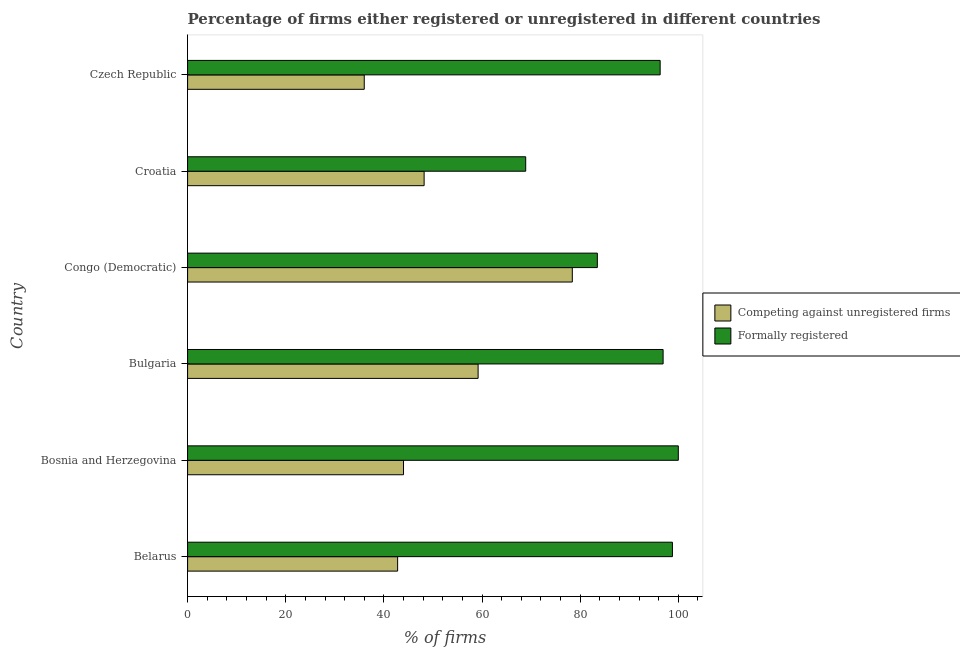What is the label of the 1st group of bars from the top?
Your answer should be compact. Czech Republic. In how many cases, is the number of bars for a given country not equal to the number of legend labels?
Your response must be concise. 0. What is the percentage of registered firms in Bosnia and Herzegovina?
Keep it short and to the point. 44. Across all countries, what is the maximum percentage of formally registered firms?
Give a very brief answer. 100. Across all countries, what is the minimum percentage of formally registered firms?
Your answer should be compact. 68.9. In which country was the percentage of registered firms maximum?
Offer a very short reply. Congo (Democratic). In which country was the percentage of formally registered firms minimum?
Give a very brief answer. Croatia. What is the total percentage of formally registered firms in the graph?
Ensure brevity in your answer.  544.4. What is the difference between the percentage of formally registered firms in Bosnia and Herzegovina and that in Czech Republic?
Your answer should be very brief. 3.7. What is the difference between the percentage of registered firms in Croatia and the percentage of formally registered firms in Congo (Democratic)?
Give a very brief answer. -35.3. What is the average percentage of formally registered firms per country?
Your answer should be very brief. 90.73. What is the difference between the percentage of formally registered firms and percentage of registered firms in Bulgaria?
Give a very brief answer. 37.7. What is the ratio of the percentage of formally registered firms in Bulgaria to that in Congo (Democratic)?
Provide a short and direct response. 1.16. What is the difference between the highest and the second highest percentage of registered firms?
Offer a very short reply. 19.2. What is the difference between the highest and the lowest percentage of formally registered firms?
Your response must be concise. 31.1. Is the sum of the percentage of formally registered firms in Belarus and Bosnia and Herzegovina greater than the maximum percentage of registered firms across all countries?
Your response must be concise. Yes. What does the 2nd bar from the top in Congo (Democratic) represents?
Provide a succinct answer. Competing against unregistered firms. What does the 1st bar from the bottom in Bosnia and Herzegovina represents?
Your answer should be very brief. Competing against unregistered firms. How many bars are there?
Provide a short and direct response. 12. Are the values on the major ticks of X-axis written in scientific E-notation?
Provide a succinct answer. No. Does the graph contain any zero values?
Provide a succinct answer. No. Does the graph contain grids?
Make the answer very short. No. Where does the legend appear in the graph?
Provide a succinct answer. Center right. How are the legend labels stacked?
Your answer should be compact. Vertical. What is the title of the graph?
Provide a short and direct response. Percentage of firms either registered or unregistered in different countries. Does "Domestic Liabilities" appear as one of the legend labels in the graph?
Offer a very short reply. No. What is the label or title of the X-axis?
Your answer should be compact. % of firms. What is the % of firms of Competing against unregistered firms in Belarus?
Give a very brief answer. 42.8. What is the % of firms in Formally registered in Belarus?
Your answer should be very brief. 98.8. What is the % of firms in Competing against unregistered firms in Bulgaria?
Your response must be concise. 59.2. What is the % of firms of Formally registered in Bulgaria?
Give a very brief answer. 96.9. What is the % of firms of Competing against unregistered firms in Congo (Democratic)?
Give a very brief answer. 78.4. What is the % of firms of Formally registered in Congo (Democratic)?
Ensure brevity in your answer.  83.5. What is the % of firms of Competing against unregistered firms in Croatia?
Keep it short and to the point. 48.2. What is the % of firms of Formally registered in Croatia?
Provide a short and direct response. 68.9. What is the % of firms of Competing against unregistered firms in Czech Republic?
Your answer should be compact. 36. What is the % of firms of Formally registered in Czech Republic?
Your response must be concise. 96.3. Across all countries, what is the maximum % of firms in Competing against unregistered firms?
Offer a terse response. 78.4. Across all countries, what is the maximum % of firms of Formally registered?
Provide a short and direct response. 100. Across all countries, what is the minimum % of firms in Formally registered?
Offer a terse response. 68.9. What is the total % of firms of Competing against unregistered firms in the graph?
Make the answer very short. 308.6. What is the total % of firms in Formally registered in the graph?
Offer a terse response. 544.4. What is the difference between the % of firms in Competing against unregistered firms in Belarus and that in Bulgaria?
Keep it short and to the point. -16.4. What is the difference between the % of firms in Competing against unregistered firms in Belarus and that in Congo (Democratic)?
Your answer should be compact. -35.6. What is the difference between the % of firms in Formally registered in Belarus and that in Croatia?
Provide a succinct answer. 29.9. What is the difference between the % of firms in Formally registered in Belarus and that in Czech Republic?
Make the answer very short. 2.5. What is the difference between the % of firms in Competing against unregistered firms in Bosnia and Herzegovina and that in Bulgaria?
Give a very brief answer. -15.2. What is the difference between the % of firms in Competing against unregistered firms in Bosnia and Herzegovina and that in Congo (Democratic)?
Your answer should be very brief. -34.4. What is the difference between the % of firms of Formally registered in Bosnia and Herzegovina and that in Croatia?
Your answer should be very brief. 31.1. What is the difference between the % of firms of Competing against unregistered firms in Bosnia and Herzegovina and that in Czech Republic?
Keep it short and to the point. 8. What is the difference between the % of firms of Formally registered in Bosnia and Herzegovina and that in Czech Republic?
Provide a short and direct response. 3.7. What is the difference between the % of firms of Competing against unregistered firms in Bulgaria and that in Congo (Democratic)?
Give a very brief answer. -19.2. What is the difference between the % of firms of Competing against unregistered firms in Bulgaria and that in Croatia?
Make the answer very short. 11. What is the difference between the % of firms in Formally registered in Bulgaria and that in Croatia?
Provide a succinct answer. 28. What is the difference between the % of firms in Competing against unregistered firms in Bulgaria and that in Czech Republic?
Offer a terse response. 23.2. What is the difference between the % of firms in Competing against unregistered firms in Congo (Democratic) and that in Croatia?
Your answer should be very brief. 30.2. What is the difference between the % of firms of Competing against unregistered firms in Congo (Democratic) and that in Czech Republic?
Your answer should be compact. 42.4. What is the difference between the % of firms of Formally registered in Croatia and that in Czech Republic?
Ensure brevity in your answer.  -27.4. What is the difference between the % of firms in Competing against unregistered firms in Belarus and the % of firms in Formally registered in Bosnia and Herzegovina?
Offer a terse response. -57.2. What is the difference between the % of firms in Competing against unregistered firms in Belarus and the % of firms in Formally registered in Bulgaria?
Give a very brief answer. -54.1. What is the difference between the % of firms in Competing against unregistered firms in Belarus and the % of firms in Formally registered in Congo (Democratic)?
Offer a terse response. -40.7. What is the difference between the % of firms in Competing against unregistered firms in Belarus and the % of firms in Formally registered in Croatia?
Offer a very short reply. -26.1. What is the difference between the % of firms in Competing against unregistered firms in Belarus and the % of firms in Formally registered in Czech Republic?
Provide a succinct answer. -53.5. What is the difference between the % of firms in Competing against unregistered firms in Bosnia and Herzegovina and the % of firms in Formally registered in Bulgaria?
Your response must be concise. -52.9. What is the difference between the % of firms in Competing against unregistered firms in Bosnia and Herzegovina and the % of firms in Formally registered in Congo (Democratic)?
Your response must be concise. -39.5. What is the difference between the % of firms of Competing against unregistered firms in Bosnia and Herzegovina and the % of firms of Formally registered in Croatia?
Make the answer very short. -24.9. What is the difference between the % of firms of Competing against unregistered firms in Bosnia and Herzegovina and the % of firms of Formally registered in Czech Republic?
Make the answer very short. -52.3. What is the difference between the % of firms in Competing against unregistered firms in Bulgaria and the % of firms in Formally registered in Congo (Democratic)?
Offer a terse response. -24.3. What is the difference between the % of firms in Competing against unregistered firms in Bulgaria and the % of firms in Formally registered in Croatia?
Provide a short and direct response. -9.7. What is the difference between the % of firms in Competing against unregistered firms in Bulgaria and the % of firms in Formally registered in Czech Republic?
Your answer should be compact. -37.1. What is the difference between the % of firms in Competing against unregistered firms in Congo (Democratic) and the % of firms in Formally registered in Czech Republic?
Offer a very short reply. -17.9. What is the difference between the % of firms in Competing against unregistered firms in Croatia and the % of firms in Formally registered in Czech Republic?
Keep it short and to the point. -48.1. What is the average % of firms in Competing against unregistered firms per country?
Make the answer very short. 51.43. What is the average % of firms in Formally registered per country?
Ensure brevity in your answer.  90.73. What is the difference between the % of firms in Competing against unregistered firms and % of firms in Formally registered in Belarus?
Provide a succinct answer. -56. What is the difference between the % of firms in Competing against unregistered firms and % of firms in Formally registered in Bosnia and Herzegovina?
Your response must be concise. -56. What is the difference between the % of firms of Competing against unregistered firms and % of firms of Formally registered in Bulgaria?
Ensure brevity in your answer.  -37.7. What is the difference between the % of firms in Competing against unregistered firms and % of firms in Formally registered in Croatia?
Give a very brief answer. -20.7. What is the difference between the % of firms of Competing against unregistered firms and % of firms of Formally registered in Czech Republic?
Offer a very short reply. -60.3. What is the ratio of the % of firms in Competing against unregistered firms in Belarus to that in Bosnia and Herzegovina?
Provide a short and direct response. 0.97. What is the ratio of the % of firms of Competing against unregistered firms in Belarus to that in Bulgaria?
Offer a very short reply. 0.72. What is the ratio of the % of firms in Formally registered in Belarus to that in Bulgaria?
Your answer should be compact. 1.02. What is the ratio of the % of firms of Competing against unregistered firms in Belarus to that in Congo (Democratic)?
Ensure brevity in your answer.  0.55. What is the ratio of the % of firms of Formally registered in Belarus to that in Congo (Democratic)?
Provide a succinct answer. 1.18. What is the ratio of the % of firms in Competing against unregistered firms in Belarus to that in Croatia?
Offer a terse response. 0.89. What is the ratio of the % of firms of Formally registered in Belarus to that in Croatia?
Give a very brief answer. 1.43. What is the ratio of the % of firms of Competing against unregistered firms in Belarus to that in Czech Republic?
Offer a very short reply. 1.19. What is the ratio of the % of firms in Formally registered in Belarus to that in Czech Republic?
Offer a terse response. 1.03. What is the ratio of the % of firms in Competing against unregistered firms in Bosnia and Herzegovina to that in Bulgaria?
Provide a succinct answer. 0.74. What is the ratio of the % of firms in Formally registered in Bosnia and Herzegovina to that in Bulgaria?
Keep it short and to the point. 1.03. What is the ratio of the % of firms in Competing against unregistered firms in Bosnia and Herzegovina to that in Congo (Democratic)?
Provide a short and direct response. 0.56. What is the ratio of the % of firms in Formally registered in Bosnia and Herzegovina to that in Congo (Democratic)?
Keep it short and to the point. 1.2. What is the ratio of the % of firms in Competing against unregistered firms in Bosnia and Herzegovina to that in Croatia?
Offer a terse response. 0.91. What is the ratio of the % of firms of Formally registered in Bosnia and Herzegovina to that in Croatia?
Offer a very short reply. 1.45. What is the ratio of the % of firms of Competing against unregistered firms in Bosnia and Herzegovina to that in Czech Republic?
Ensure brevity in your answer.  1.22. What is the ratio of the % of firms of Formally registered in Bosnia and Herzegovina to that in Czech Republic?
Your answer should be compact. 1.04. What is the ratio of the % of firms of Competing against unregistered firms in Bulgaria to that in Congo (Democratic)?
Give a very brief answer. 0.76. What is the ratio of the % of firms in Formally registered in Bulgaria to that in Congo (Democratic)?
Offer a very short reply. 1.16. What is the ratio of the % of firms of Competing against unregistered firms in Bulgaria to that in Croatia?
Give a very brief answer. 1.23. What is the ratio of the % of firms of Formally registered in Bulgaria to that in Croatia?
Offer a terse response. 1.41. What is the ratio of the % of firms in Competing against unregistered firms in Bulgaria to that in Czech Republic?
Ensure brevity in your answer.  1.64. What is the ratio of the % of firms in Formally registered in Bulgaria to that in Czech Republic?
Provide a succinct answer. 1.01. What is the ratio of the % of firms of Competing against unregistered firms in Congo (Democratic) to that in Croatia?
Give a very brief answer. 1.63. What is the ratio of the % of firms in Formally registered in Congo (Democratic) to that in Croatia?
Give a very brief answer. 1.21. What is the ratio of the % of firms in Competing against unregistered firms in Congo (Democratic) to that in Czech Republic?
Keep it short and to the point. 2.18. What is the ratio of the % of firms of Formally registered in Congo (Democratic) to that in Czech Republic?
Your answer should be very brief. 0.87. What is the ratio of the % of firms of Competing against unregistered firms in Croatia to that in Czech Republic?
Your answer should be compact. 1.34. What is the ratio of the % of firms in Formally registered in Croatia to that in Czech Republic?
Keep it short and to the point. 0.72. What is the difference between the highest and the second highest % of firms in Formally registered?
Offer a terse response. 1.2. What is the difference between the highest and the lowest % of firms of Competing against unregistered firms?
Ensure brevity in your answer.  42.4. What is the difference between the highest and the lowest % of firms in Formally registered?
Provide a succinct answer. 31.1. 